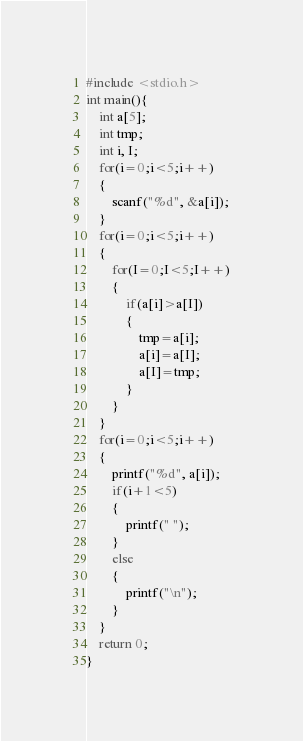<code> <loc_0><loc_0><loc_500><loc_500><_C_>#include <stdio.h>
int main(){
	int a[5];
	int tmp;
	int i, I;
	for(i=0;i<5;i++)
	{
		scanf("%d", &a[i]);
	}
	for(i=0;i<5;i++)
	{
		for(I=0;I<5;I++)
		{
			if(a[i]>a[I])
			{
				tmp=a[i];
				a[i]=a[I];
				a[I]=tmp;
			}
		}
	}
	for(i=0;i<5;i++)
	{
		printf("%d", a[i]);
		if(i+1<5)
		{
			printf(" ");
		}
		else
		{
			printf("\n");
		}
	}
	return 0;
}</code> 